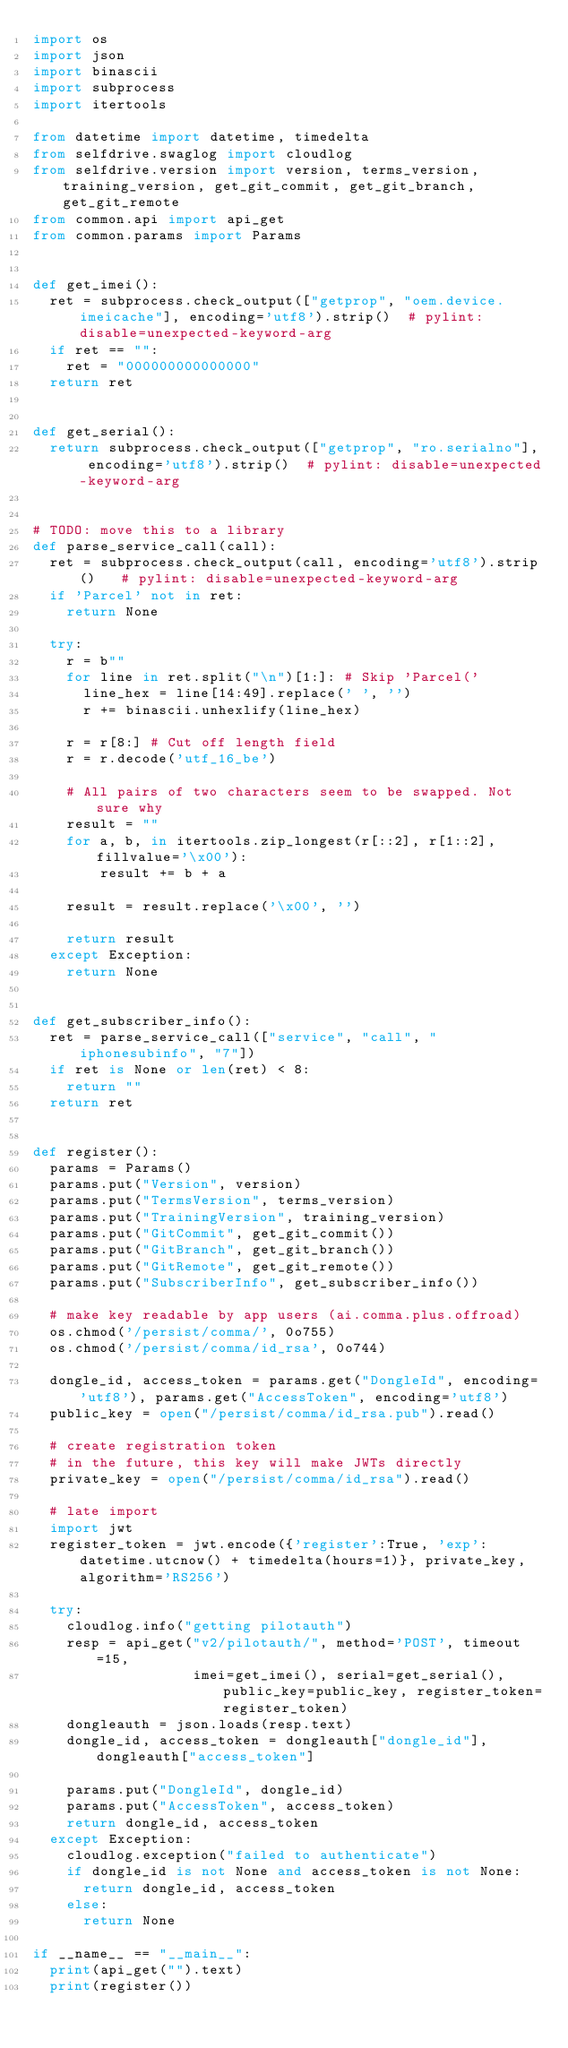Convert code to text. <code><loc_0><loc_0><loc_500><loc_500><_Python_>import os
import json
import binascii
import subprocess
import itertools

from datetime import datetime, timedelta
from selfdrive.swaglog import cloudlog
from selfdrive.version import version, terms_version, training_version, get_git_commit, get_git_branch, get_git_remote
from common.api import api_get
from common.params import Params


def get_imei():
  ret = subprocess.check_output(["getprop", "oem.device.imeicache"], encoding='utf8').strip()  # pylint: disable=unexpected-keyword-arg
  if ret == "":
    ret = "000000000000000"
  return ret


def get_serial():
  return subprocess.check_output(["getprop", "ro.serialno"], encoding='utf8').strip()  # pylint: disable=unexpected-keyword-arg


# TODO: move this to a library
def parse_service_call(call):
  ret = subprocess.check_output(call, encoding='utf8').strip()   # pylint: disable=unexpected-keyword-arg
  if 'Parcel' not in ret:
    return None

  try:
    r = b""
    for line in ret.split("\n")[1:]: # Skip 'Parcel('
      line_hex = line[14:49].replace(' ', '')
      r += binascii.unhexlify(line_hex)

    r = r[8:] # Cut off length field
    r = r.decode('utf_16_be')

    # All pairs of two characters seem to be swapped. Not sure why
    result = ""
    for a, b, in itertools.zip_longest(r[::2], r[1::2], fillvalue='\x00'):
        result += b + a

    result = result.replace('\x00', '')

    return result
  except Exception:
    return None


def get_subscriber_info():
  ret = parse_service_call(["service", "call", "iphonesubinfo", "7"])
  if ret is None or len(ret) < 8:
    return ""
  return ret


def register():
  params = Params()
  params.put("Version", version)
  params.put("TermsVersion", terms_version)
  params.put("TrainingVersion", training_version)
  params.put("GitCommit", get_git_commit())
  params.put("GitBranch", get_git_branch())
  params.put("GitRemote", get_git_remote())
  params.put("SubscriberInfo", get_subscriber_info())

  # make key readable by app users (ai.comma.plus.offroad)
  os.chmod('/persist/comma/', 0o755)
  os.chmod('/persist/comma/id_rsa', 0o744)

  dongle_id, access_token = params.get("DongleId", encoding='utf8'), params.get("AccessToken", encoding='utf8')
  public_key = open("/persist/comma/id_rsa.pub").read()

  # create registration token
  # in the future, this key will make JWTs directly
  private_key = open("/persist/comma/id_rsa").read()

  # late import
  import jwt
  register_token = jwt.encode({'register':True, 'exp': datetime.utcnow() + timedelta(hours=1)}, private_key, algorithm='RS256')

  try:
    cloudlog.info("getting pilotauth")
    resp = api_get("v2/pilotauth/", method='POST', timeout=15,
                   imei=get_imei(), serial=get_serial(), public_key=public_key, register_token=register_token)
    dongleauth = json.loads(resp.text)
    dongle_id, access_token = dongleauth["dongle_id"], dongleauth["access_token"]

    params.put("DongleId", dongle_id)
    params.put("AccessToken", access_token)
    return dongle_id, access_token
  except Exception:
    cloudlog.exception("failed to authenticate")
    if dongle_id is not None and access_token is not None:
      return dongle_id, access_token
    else:
      return None

if __name__ == "__main__":
  print(api_get("").text)
  print(register())
</code> 